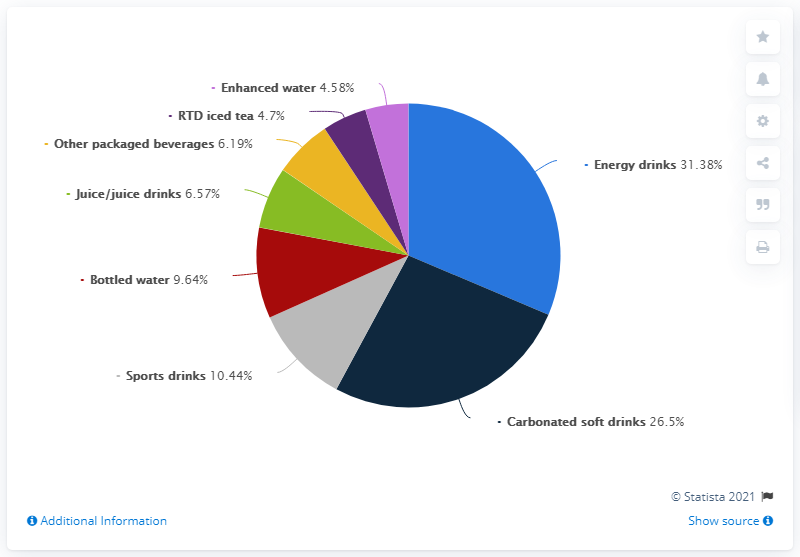List a handful of essential elements in this visual. Energy drinks sales are significantly higher than the average sales of all drinks, with a reported figure of 18.88. The red bar represents bottled water. 